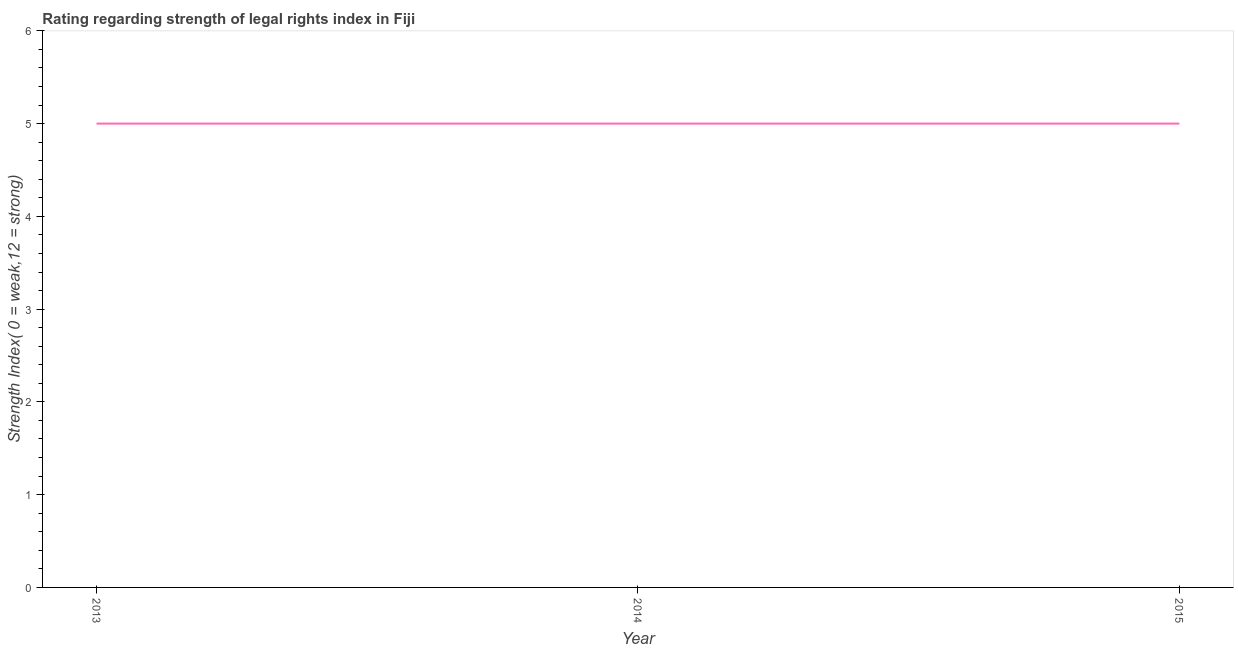What is the strength of legal rights index in 2014?
Your answer should be very brief. 5. Across all years, what is the maximum strength of legal rights index?
Offer a very short reply. 5. Across all years, what is the minimum strength of legal rights index?
Offer a very short reply. 5. What is the sum of the strength of legal rights index?
Keep it short and to the point. 15. Do a majority of the years between 2015 and 2014 (inclusive) have strength of legal rights index greater than 0.2 ?
Provide a succinct answer. No. Is the strength of legal rights index in 2013 less than that in 2015?
Make the answer very short. No. Is the sum of the strength of legal rights index in 2013 and 2015 greater than the maximum strength of legal rights index across all years?
Give a very brief answer. Yes. What is the difference between the highest and the lowest strength of legal rights index?
Provide a short and direct response. 0. In how many years, is the strength of legal rights index greater than the average strength of legal rights index taken over all years?
Your answer should be compact. 0. Does the strength of legal rights index monotonically increase over the years?
Your response must be concise. No. How many lines are there?
Ensure brevity in your answer.  1. How many years are there in the graph?
Provide a succinct answer. 3. What is the difference between two consecutive major ticks on the Y-axis?
Your response must be concise. 1. What is the title of the graph?
Ensure brevity in your answer.  Rating regarding strength of legal rights index in Fiji. What is the label or title of the Y-axis?
Make the answer very short. Strength Index( 0 = weak,12 = strong). What is the Strength Index( 0 = weak,12 = strong) of 2013?
Give a very brief answer. 5. What is the Strength Index( 0 = weak,12 = strong) in 2014?
Ensure brevity in your answer.  5. What is the difference between the Strength Index( 0 = weak,12 = strong) in 2013 and 2015?
Provide a succinct answer. 0. What is the difference between the Strength Index( 0 = weak,12 = strong) in 2014 and 2015?
Give a very brief answer. 0. What is the ratio of the Strength Index( 0 = weak,12 = strong) in 2013 to that in 2014?
Offer a very short reply. 1. 